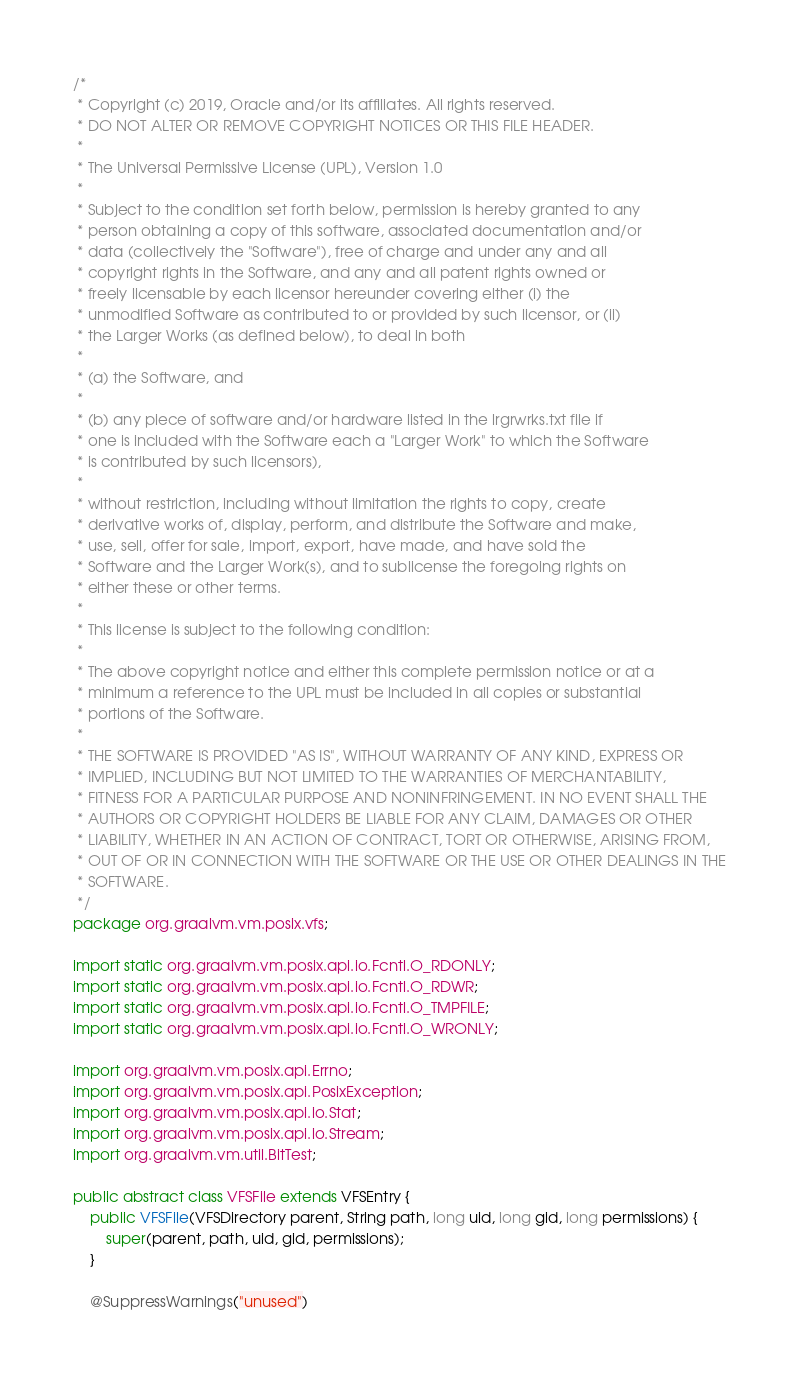Convert code to text. <code><loc_0><loc_0><loc_500><loc_500><_Java_>/*
 * Copyright (c) 2019, Oracle and/or its affiliates. All rights reserved.
 * DO NOT ALTER OR REMOVE COPYRIGHT NOTICES OR THIS FILE HEADER.
 *
 * The Universal Permissive License (UPL), Version 1.0
 *
 * Subject to the condition set forth below, permission is hereby granted to any
 * person obtaining a copy of this software, associated documentation and/or
 * data (collectively the "Software"), free of charge and under any and all
 * copyright rights in the Software, and any and all patent rights owned or
 * freely licensable by each licensor hereunder covering either (i) the
 * unmodified Software as contributed to or provided by such licensor, or (ii)
 * the Larger Works (as defined below), to deal in both
 *
 * (a) the Software, and
 *
 * (b) any piece of software and/or hardware listed in the lrgrwrks.txt file if
 * one is included with the Software each a "Larger Work" to which the Software
 * is contributed by such licensors),
 *
 * without restriction, including without limitation the rights to copy, create
 * derivative works of, display, perform, and distribute the Software and make,
 * use, sell, offer for sale, import, export, have made, and have sold the
 * Software and the Larger Work(s), and to sublicense the foregoing rights on
 * either these or other terms.
 *
 * This license is subject to the following condition:
 *
 * The above copyright notice and either this complete permission notice or at a
 * minimum a reference to the UPL must be included in all copies or substantial
 * portions of the Software.
 *
 * THE SOFTWARE IS PROVIDED "AS IS", WITHOUT WARRANTY OF ANY KIND, EXPRESS OR
 * IMPLIED, INCLUDING BUT NOT LIMITED TO THE WARRANTIES OF MERCHANTABILITY,
 * FITNESS FOR A PARTICULAR PURPOSE AND NONINFRINGEMENT. IN NO EVENT SHALL THE
 * AUTHORS OR COPYRIGHT HOLDERS BE LIABLE FOR ANY CLAIM, DAMAGES OR OTHER
 * LIABILITY, WHETHER IN AN ACTION OF CONTRACT, TORT OR OTHERWISE, ARISING FROM,
 * OUT OF OR IN CONNECTION WITH THE SOFTWARE OR THE USE OR OTHER DEALINGS IN THE
 * SOFTWARE.
 */
package org.graalvm.vm.posix.vfs;

import static org.graalvm.vm.posix.api.io.Fcntl.O_RDONLY;
import static org.graalvm.vm.posix.api.io.Fcntl.O_RDWR;
import static org.graalvm.vm.posix.api.io.Fcntl.O_TMPFILE;
import static org.graalvm.vm.posix.api.io.Fcntl.O_WRONLY;

import org.graalvm.vm.posix.api.Errno;
import org.graalvm.vm.posix.api.PosixException;
import org.graalvm.vm.posix.api.io.Stat;
import org.graalvm.vm.posix.api.io.Stream;
import org.graalvm.vm.util.BitTest;

public abstract class VFSFile extends VFSEntry {
    public VFSFile(VFSDirectory parent, String path, long uid, long gid, long permissions) {
        super(parent, path, uid, gid, permissions);
    }

    @SuppressWarnings("unused")</code> 